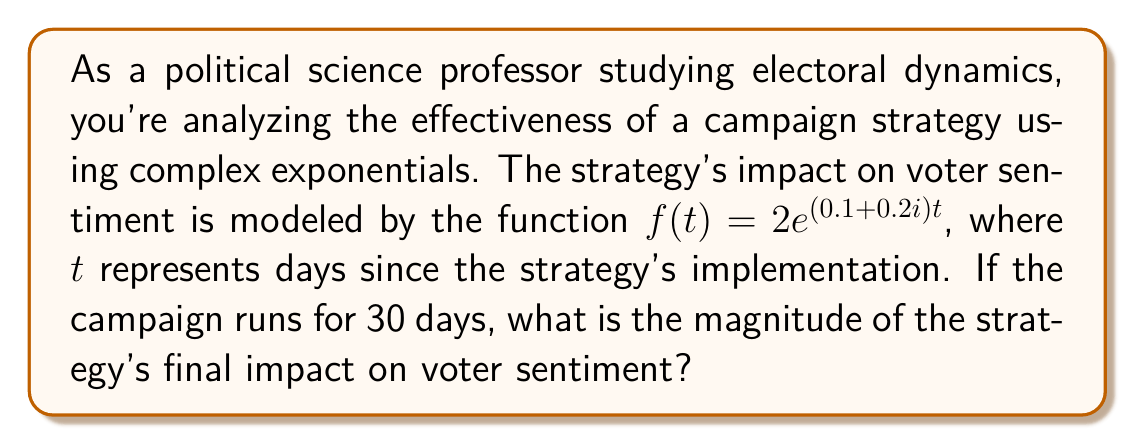Could you help me with this problem? To solve this problem, we need to follow these steps:

1) The given function is $f(t) = 2e^{(0.1+0.2i)t}$

2) We need to find $|f(30)|$, as the campaign runs for 30 days.

3) For a complex exponential of the form $e^{(a+bi)t}$, the magnitude is given by $e^{at}$

4) In our case, $a = 0.1$ and $t = 30$

5) The magnitude of the final impact will be:

   $$|f(30)| = 2|e^{(0.1+0.2i)30}| = 2e^{0.1 \cdot 30} = 2e^3$$

6) Calculate $e^3$:
   
   $$e^3 \approx 20.0855$$

7) Multiply by 2:

   $$2e^3 \approx 2 \cdot 20.0855 = 40.1710$$

Therefore, the magnitude of the strategy's final impact on voter sentiment after 30 days is approximately 40.1710.
Answer: $40.1710$ (rounded to 4 decimal places) 